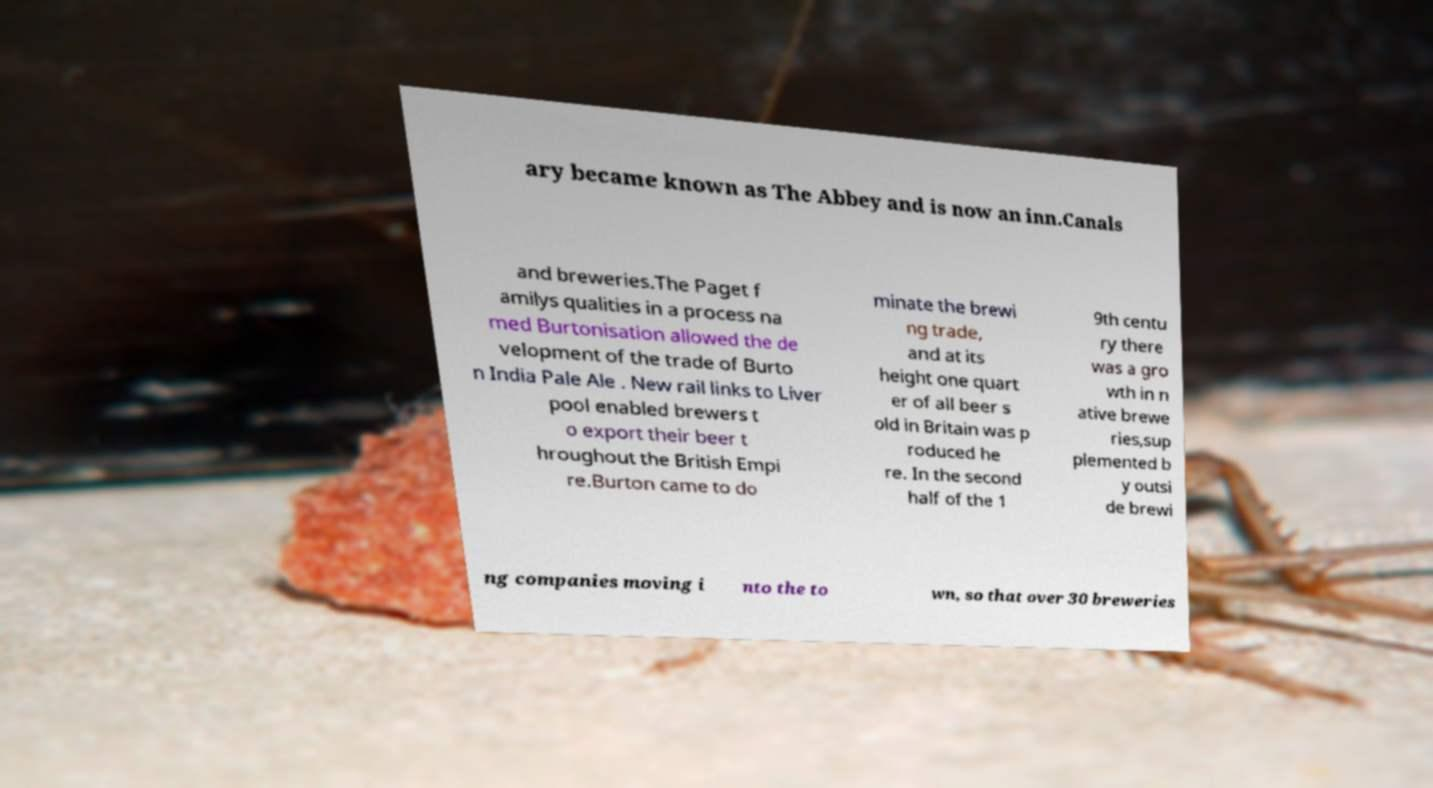What messages or text are displayed in this image? I need them in a readable, typed format. ary became known as The Abbey and is now an inn.Canals and breweries.The Paget f amilys qualities in a process na med Burtonisation allowed the de velopment of the trade of Burto n India Pale Ale . New rail links to Liver pool enabled brewers t o export their beer t hroughout the British Empi re.Burton came to do minate the brewi ng trade, and at its height one quart er of all beer s old in Britain was p roduced he re. In the second half of the 1 9th centu ry there was a gro wth in n ative brewe ries,sup plemented b y outsi de brewi ng companies moving i nto the to wn, so that over 30 breweries 